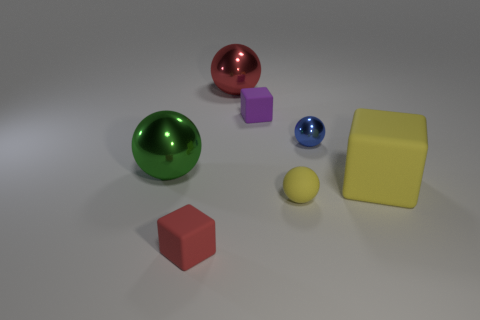Subtract all blue spheres. How many spheres are left? 3 Add 2 small brown rubber balls. How many objects exist? 9 Subtract all cyan spheres. Subtract all cyan cylinders. How many spheres are left? 4 Subtract all blocks. How many objects are left? 4 Add 6 yellow matte balls. How many yellow matte balls are left? 7 Add 4 large yellow matte cubes. How many large yellow matte cubes exist? 5 Subtract 0 cyan cylinders. How many objects are left? 7 Subtract all large blue balls. Subtract all tiny purple rubber things. How many objects are left? 6 